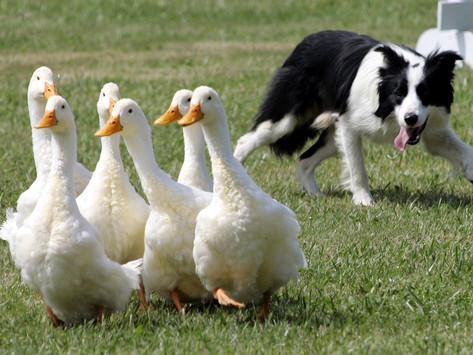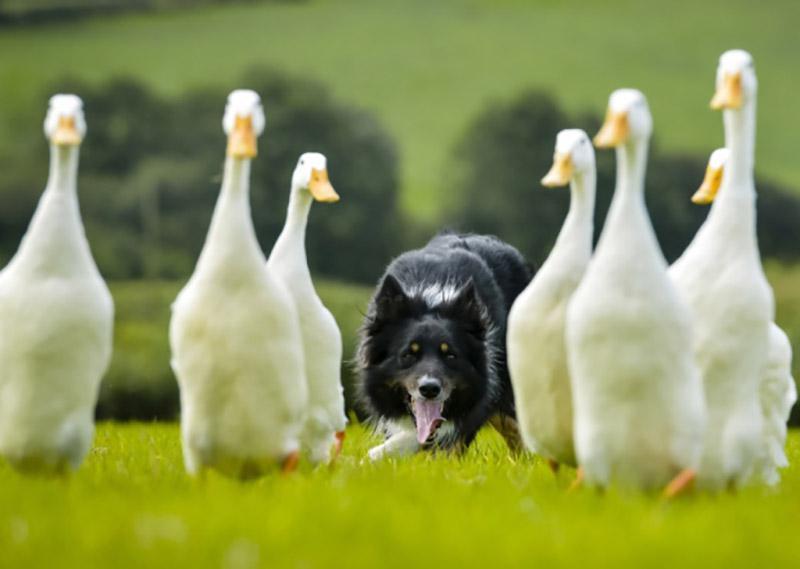The first image is the image on the left, the second image is the image on the right. Examine the images to the left and right. Is the description "At least one image shows a dog at the right herding no more than three sheep, which are at the left." accurate? Answer yes or no. No. 